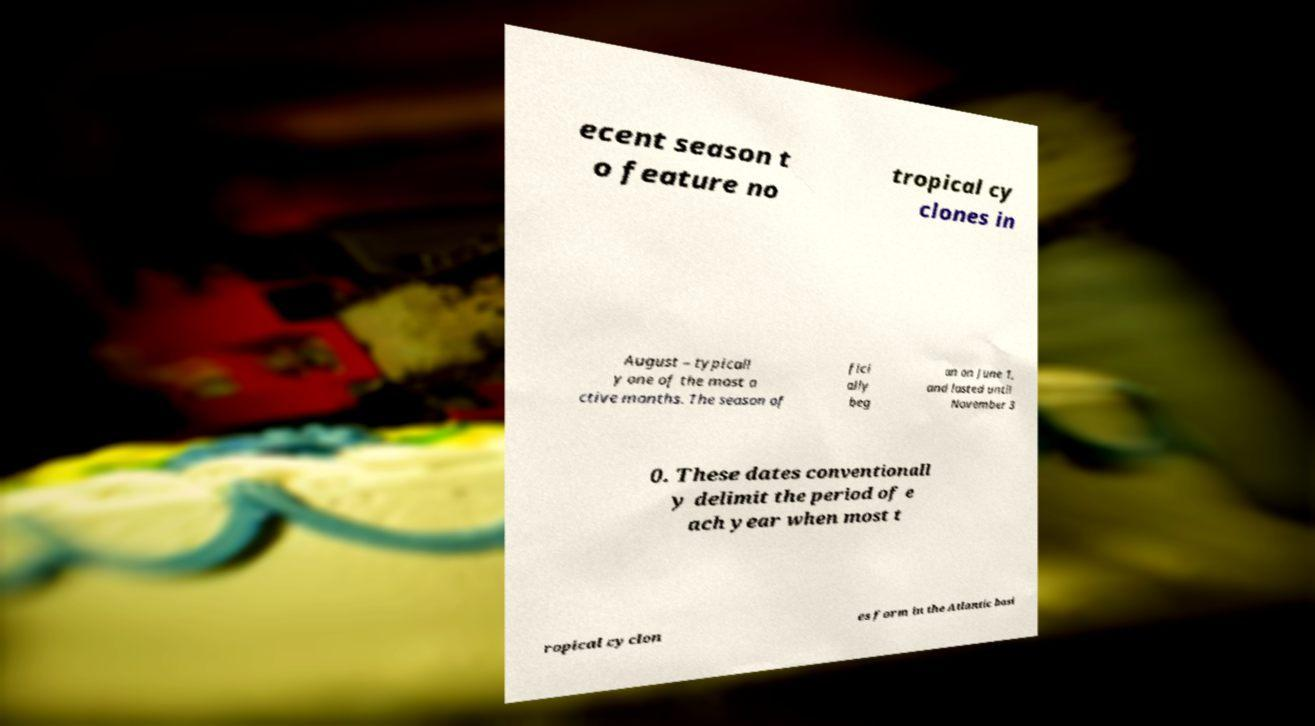I need the written content from this picture converted into text. Can you do that? ecent season t o feature no tropical cy clones in August – typicall y one of the most a ctive months. The season of fici ally beg an on June 1, and lasted until November 3 0. These dates conventionall y delimit the period of e ach year when most t ropical cyclon es form in the Atlantic basi 